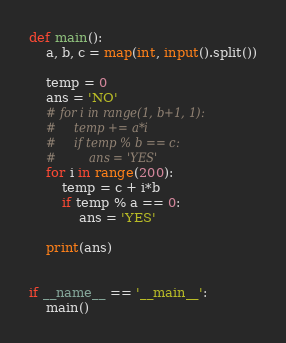<code> <loc_0><loc_0><loc_500><loc_500><_Python_>def main():
    a, b, c = map(int, input().split())

    temp = 0
    ans = 'NO'
    # for i in range(1, b+1, 1):
    #     temp += a*i
    #     if temp % b == c:
    #         ans = 'YES'
    for i in range(200):
        temp = c + i*b
        if temp % a == 0:
            ans = 'YES'

    print(ans)


if __name__ == '__main__':
    main()
</code> 